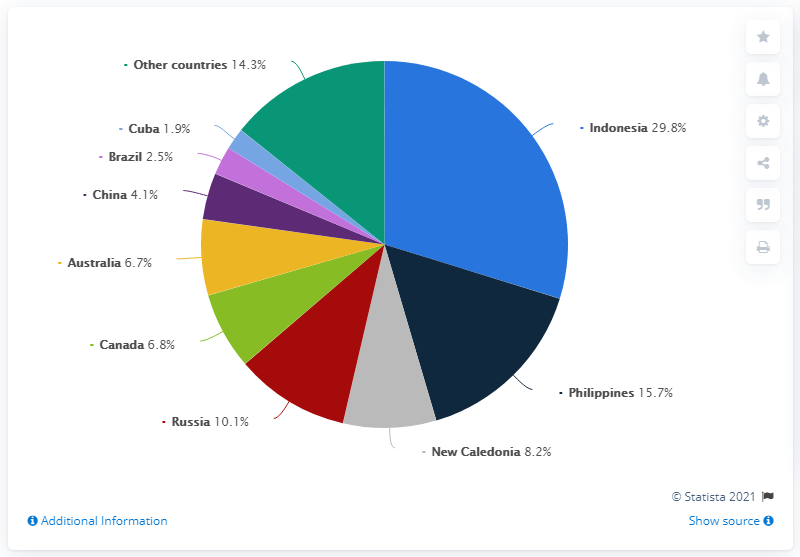Point out several critical features in this image. Australia and Canada are the two countries with the closest mine production of nickel to each other. In 2019, Indonesia produced 29.8% of the world's nickel supply. There are 10 different colored segments in the pie chart. The Philippines had the second highest nickel production in 2019. 